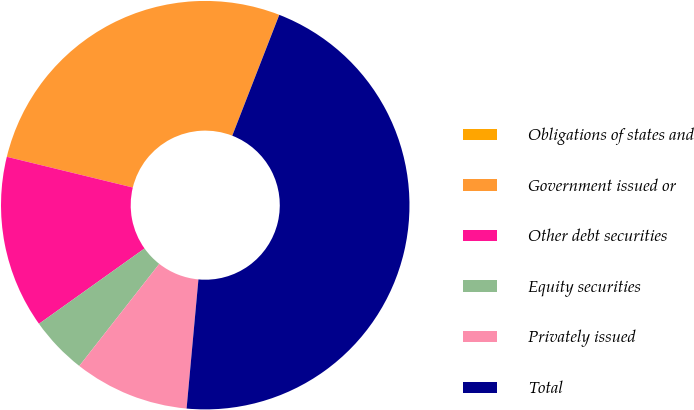<chart> <loc_0><loc_0><loc_500><loc_500><pie_chart><fcel>Obligations of states and<fcel>Government issued or<fcel>Other debt securities<fcel>Equity securities<fcel>Privately issued<fcel>Total<nl><fcel>0.01%<fcel>27.09%<fcel>13.67%<fcel>4.56%<fcel>9.12%<fcel>45.55%<nl></chart> 